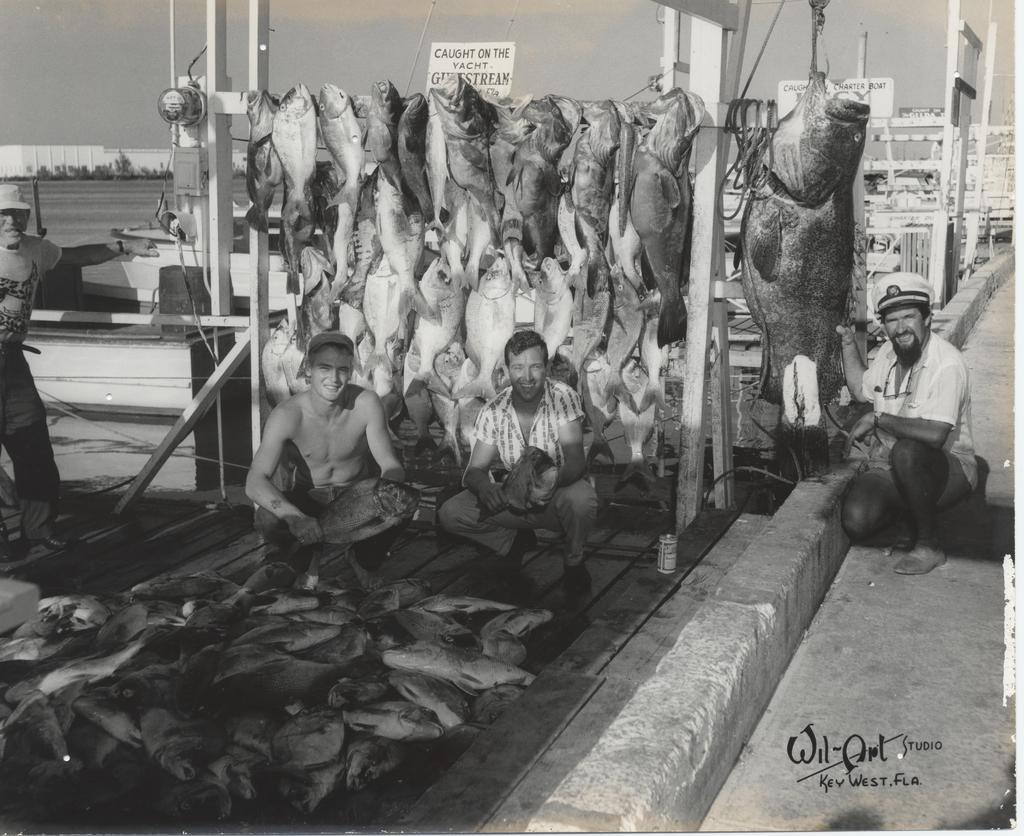Can you describe this image briefly? In this picture we can see fishes, there are four persons in the middle, in the background there are some plants, we can also see two boards in the middle, it is a black and white image, there is some text at the right bottom. 